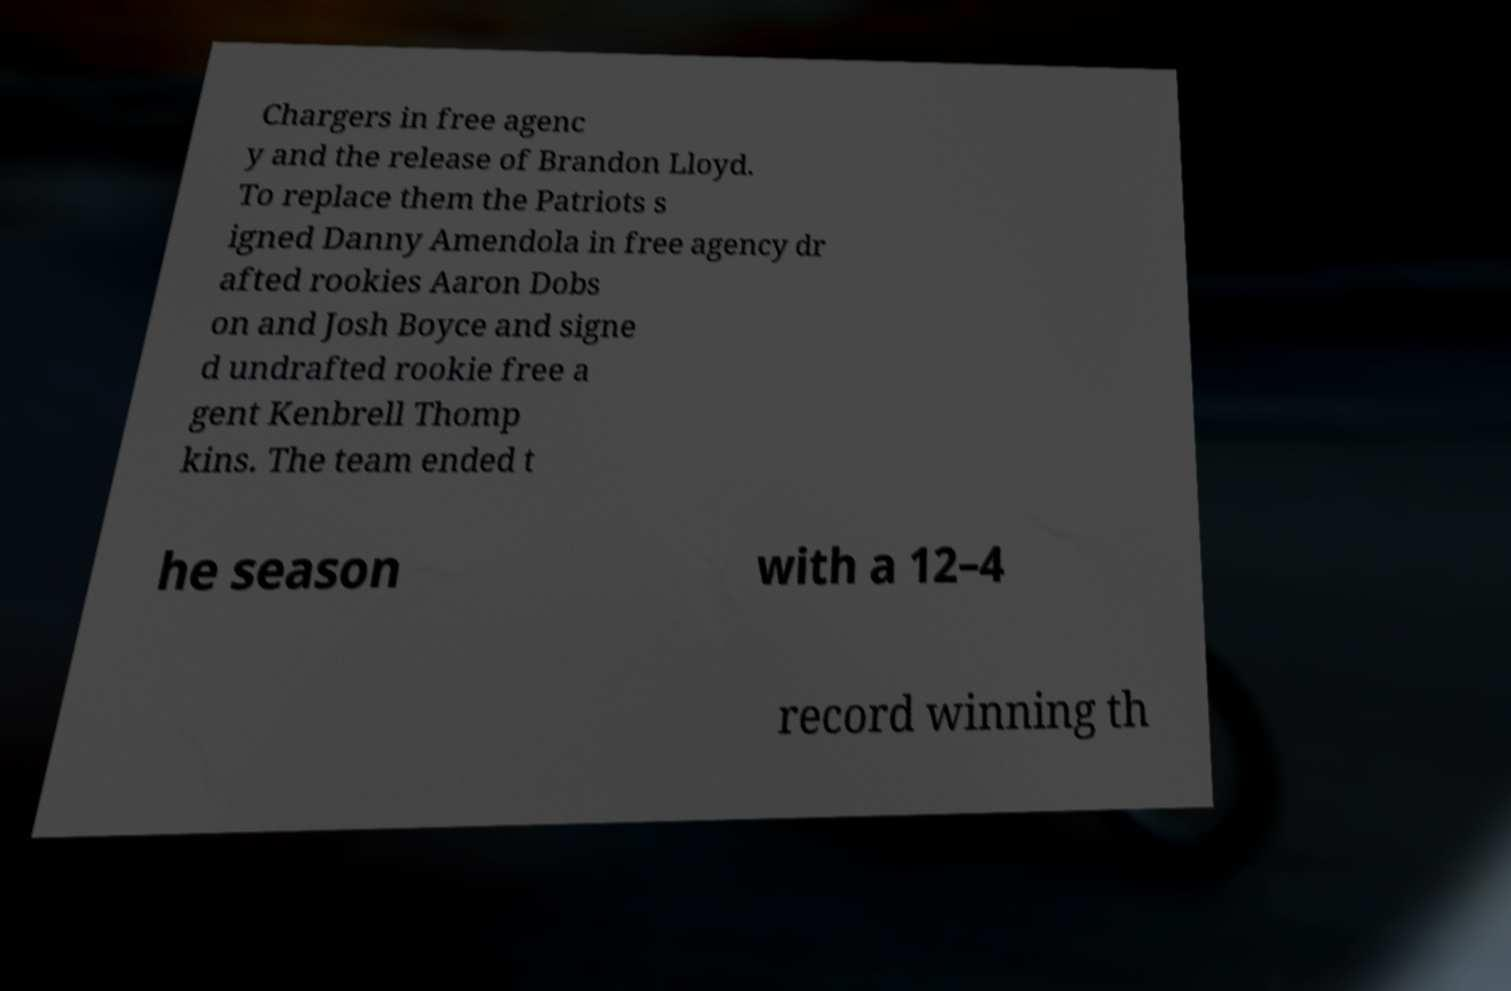There's text embedded in this image that I need extracted. Can you transcribe it verbatim? Chargers in free agenc y and the release of Brandon Lloyd. To replace them the Patriots s igned Danny Amendola in free agency dr afted rookies Aaron Dobs on and Josh Boyce and signe d undrafted rookie free a gent Kenbrell Thomp kins. The team ended t he season with a 12–4 record winning th 